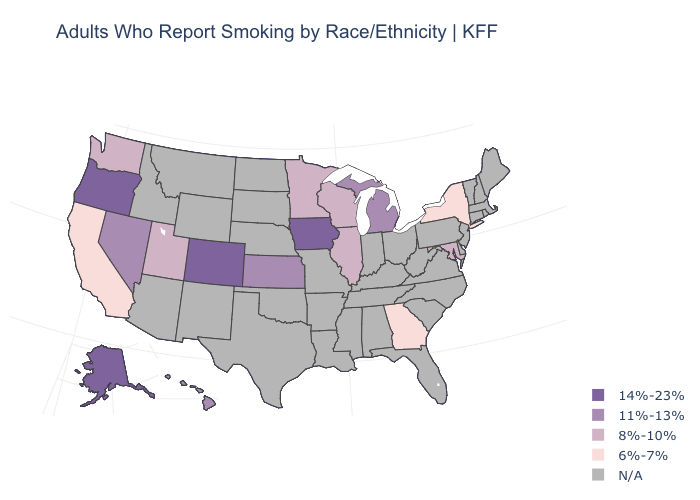Which states have the highest value in the USA?
Write a very short answer. Alaska, Colorado, Iowa, Oregon. Does the first symbol in the legend represent the smallest category?
Be succinct. No. Does Georgia have the lowest value in the USA?
Quick response, please. Yes. Which states have the lowest value in the USA?
Short answer required. California, Georgia, New York. What is the value of Kansas?
Write a very short answer. 11%-13%. Name the states that have a value in the range 14%-23%?
Answer briefly. Alaska, Colorado, Iowa, Oregon. Name the states that have a value in the range N/A?
Concise answer only. Alabama, Arizona, Arkansas, Connecticut, Delaware, Florida, Idaho, Indiana, Kentucky, Louisiana, Maine, Massachusetts, Mississippi, Missouri, Montana, Nebraska, New Hampshire, New Jersey, New Mexico, North Carolina, North Dakota, Ohio, Oklahoma, Pennsylvania, Rhode Island, South Carolina, South Dakota, Tennessee, Texas, Vermont, Virginia, West Virginia, Wyoming. Does Georgia have the lowest value in the South?
Write a very short answer. Yes. Does the map have missing data?
Quick response, please. Yes. What is the highest value in the MidWest ?
Give a very brief answer. 14%-23%. 